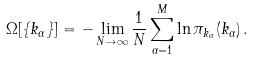<formula> <loc_0><loc_0><loc_500><loc_500>\Omega [ \{ k _ { \alpha } \} ] = - \lim _ { N \to \infty } \frac { 1 } { N } \sum _ { \alpha = 1 } ^ { M } \ln \pi _ { k _ { \alpha } } ( k _ { \alpha } ) \, .</formula> 